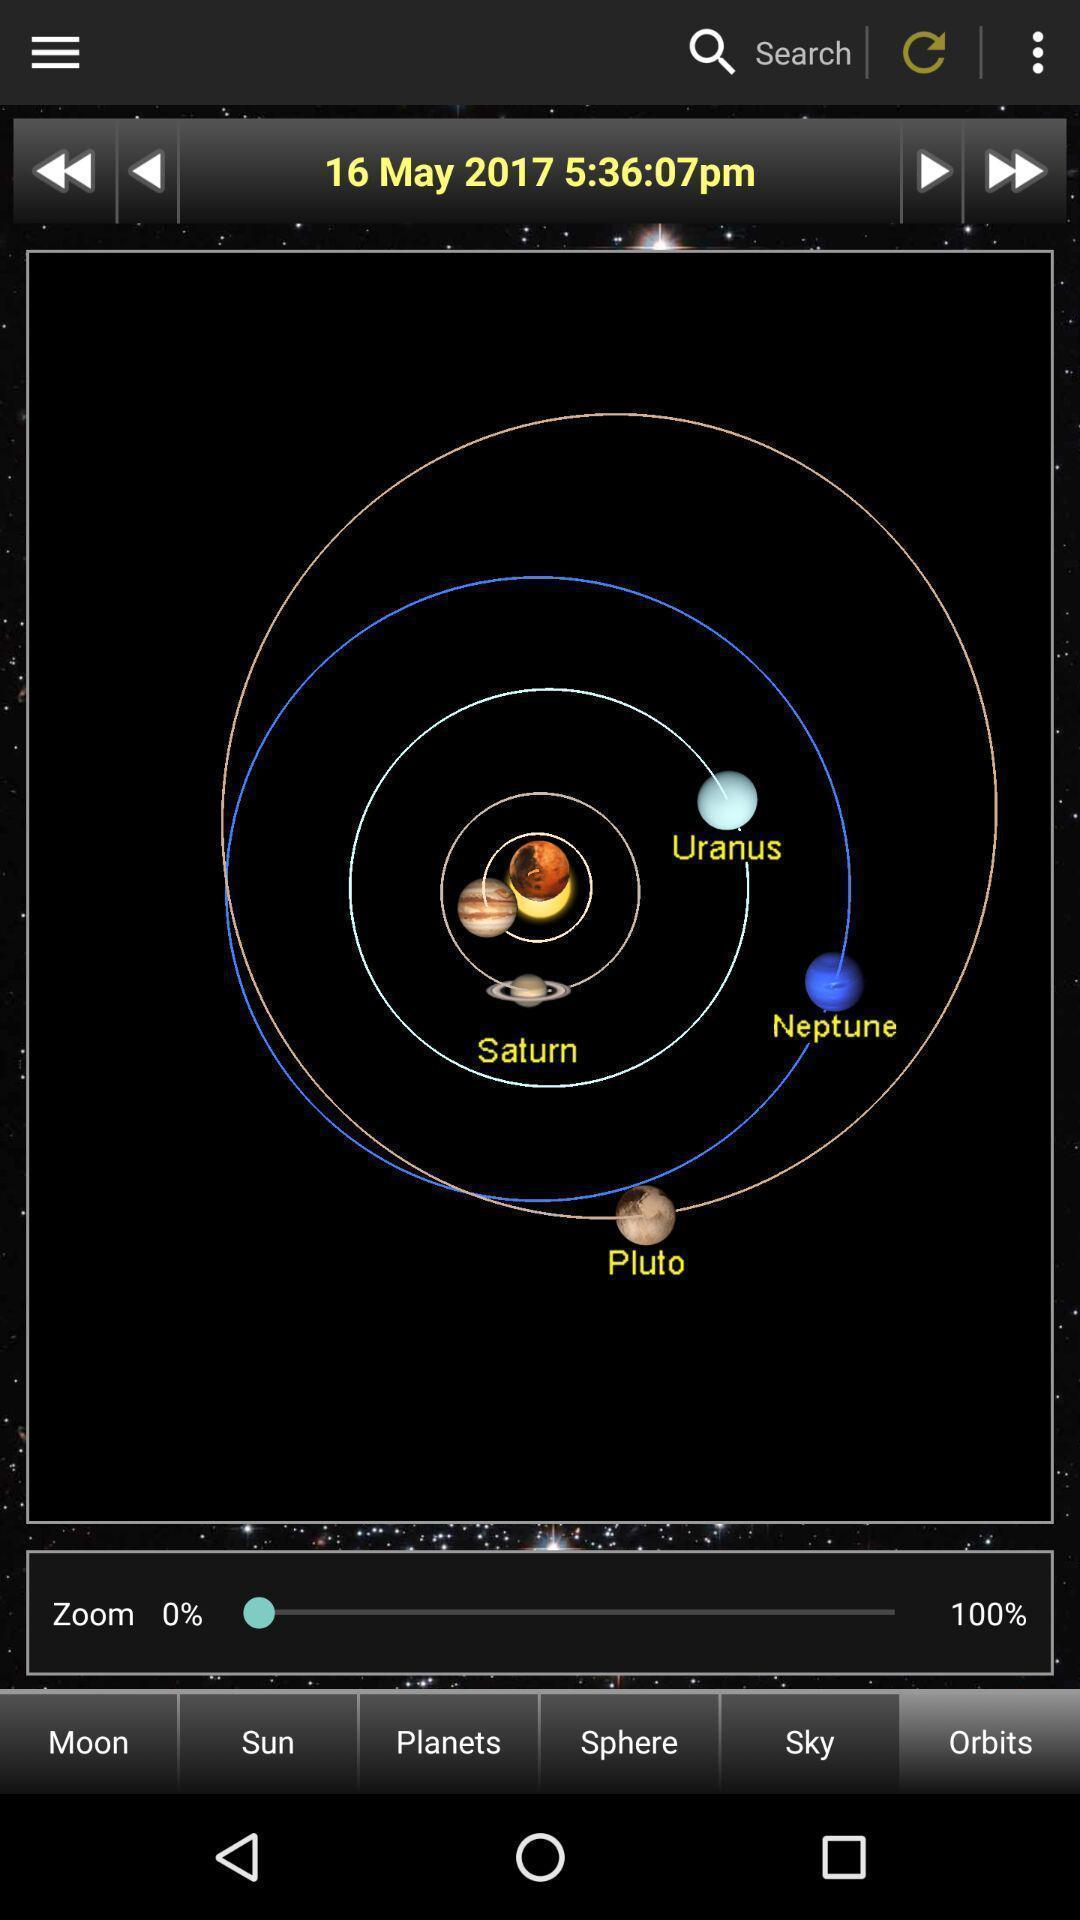Give me a narrative description of this picture. Screen showing the solar system. 